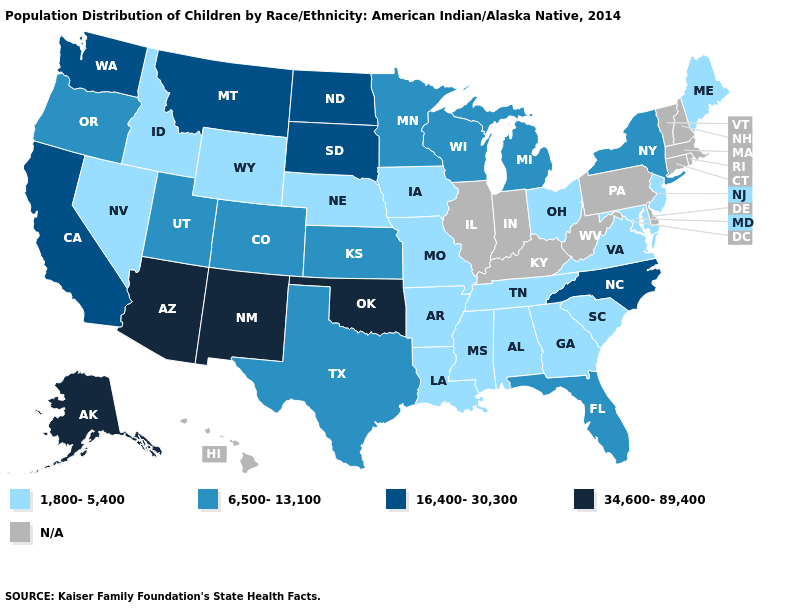Does New York have the lowest value in the USA?
Give a very brief answer. No. How many symbols are there in the legend?
Short answer required. 5. What is the value of Virginia?
Be succinct. 1,800-5,400. What is the highest value in the West ?
Keep it brief. 34,600-89,400. What is the lowest value in states that border North Dakota?
Concise answer only. 6,500-13,100. Which states have the lowest value in the West?
Keep it brief. Idaho, Nevada, Wyoming. Does Oklahoma have the highest value in the South?
Write a very short answer. Yes. Name the states that have a value in the range 6,500-13,100?
Quick response, please. Colorado, Florida, Kansas, Michigan, Minnesota, New York, Oregon, Texas, Utah, Wisconsin. Among the states that border Idaho , does Nevada have the lowest value?
Short answer required. Yes. Does Texas have the lowest value in the South?
Keep it brief. No. What is the highest value in the Northeast ?
Quick response, please. 6,500-13,100. What is the value of Rhode Island?
Short answer required. N/A. What is the lowest value in the USA?
Short answer required. 1,800-5,400. Name the states that have a value in the range 34,600-89,400?
Quick response, please. Alaska, Arizona, New Mexico, Oklahoma. 